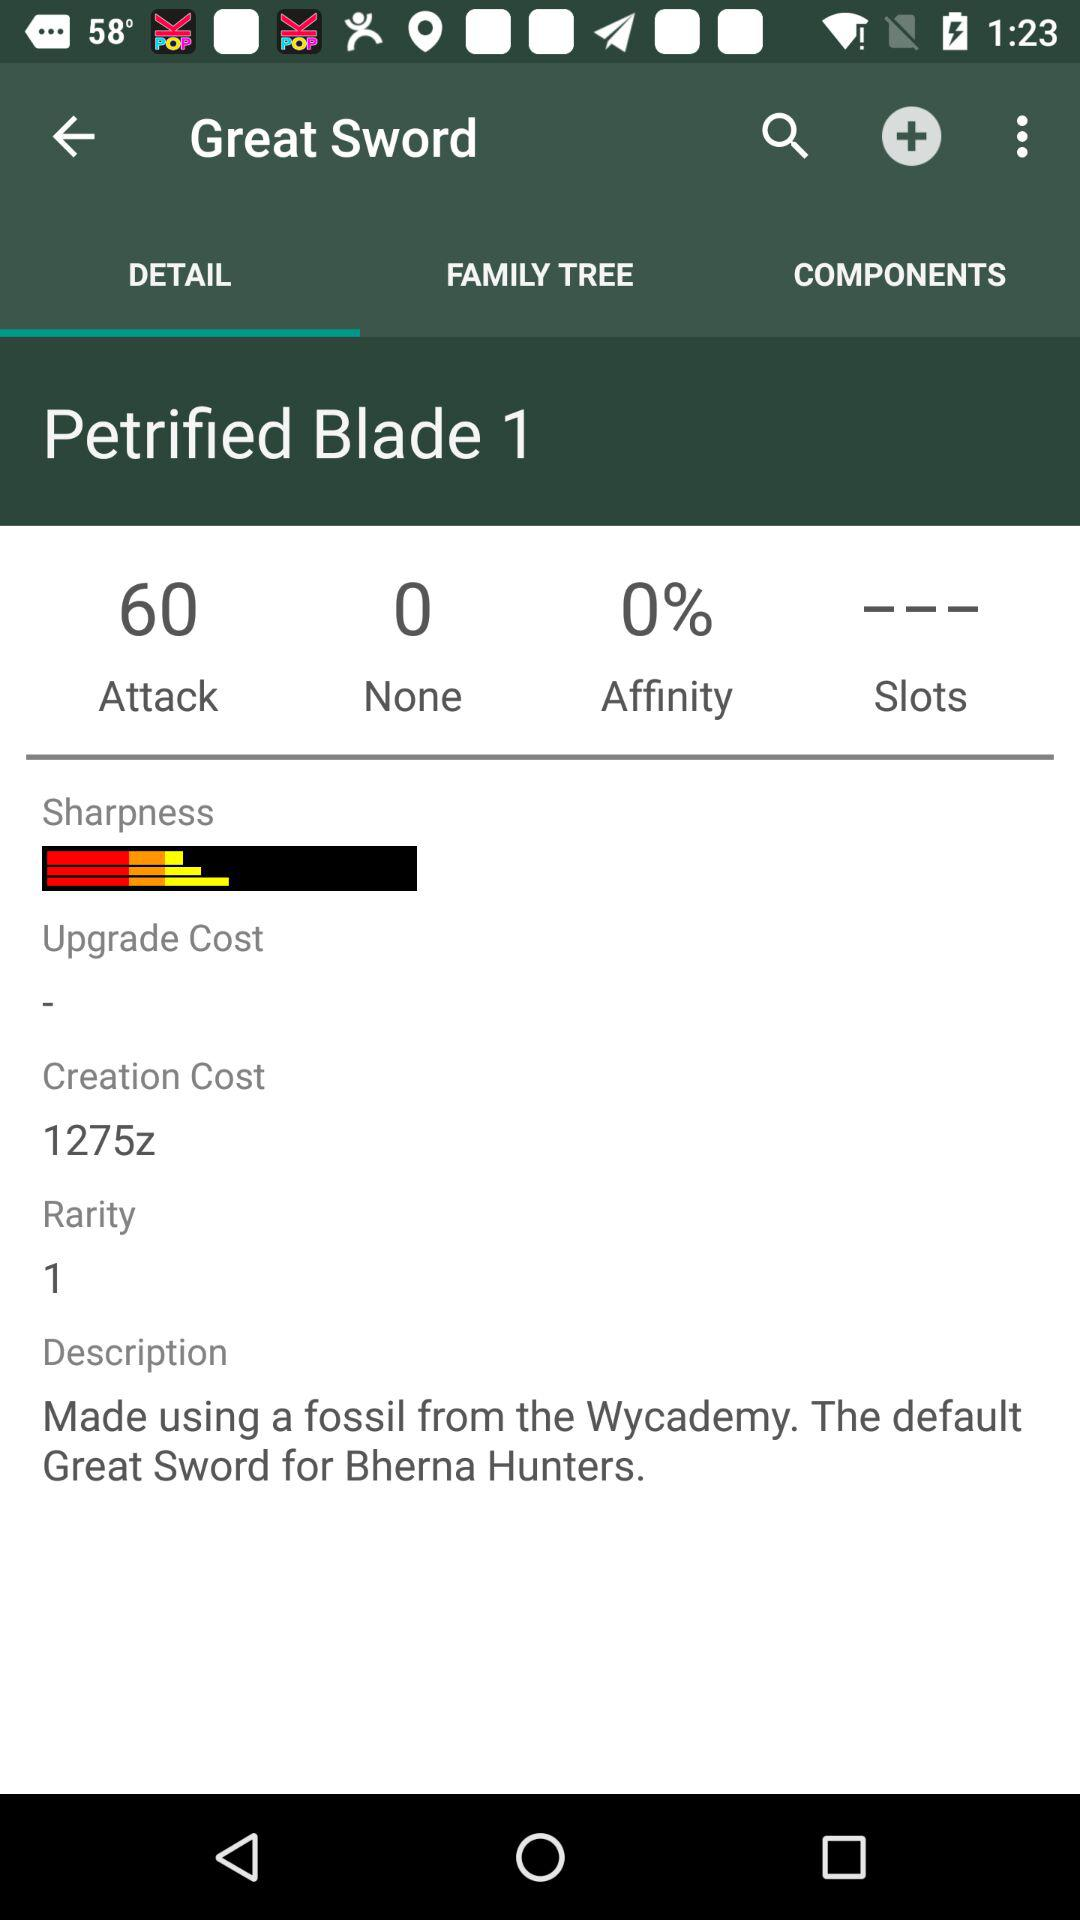What is the Great Sword made up of? The Great Sword is made up of a fossil from the "Wycademy". 